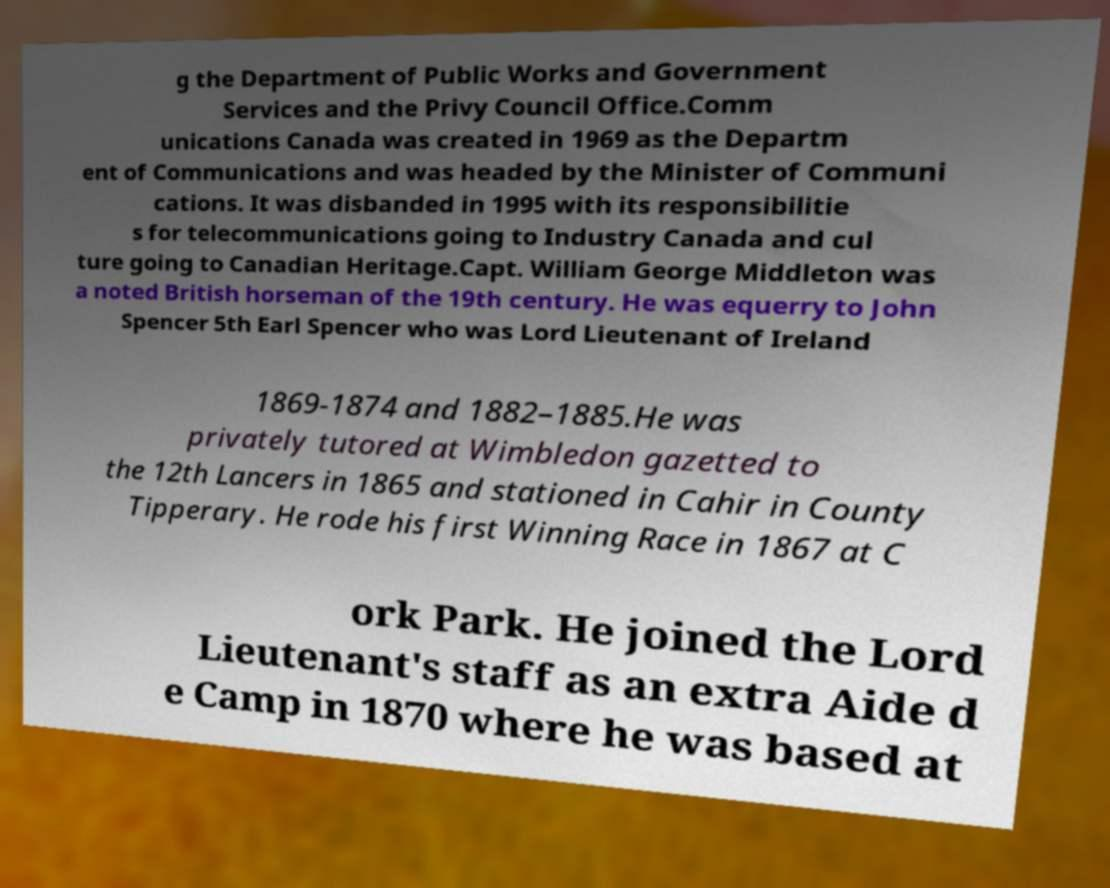Please read and relay the text visible in this image. What does it say? g the Department of Public Works and Government Services and the Privy Council Office.Comm unications Canada was created in 1969 as the Departm ent of Communications and was headed by the Minister of Communi cations. It was disbanded in 1995 with its responsibilitie s for telecommunications going to Industry Canada and cul ture going to Canadian Heritage.Capt. William George Middleton was a noted British horseman of the 19th century. He was equerry to John Spencer 5th Earl Spencer who was Lord Lieutenant of Ireland 1869-1874 and 1882–1885.He was privately tutored at Wimbledon gazetted to the 12th Lancers in 1865 and stationed in Cahir in County Tipperary. He rode his first Winning Race in 1867 at C ork Park. He joined the Lord Lieutenant's staff as an extra Aide d e Camp in 1870 where he was based at 